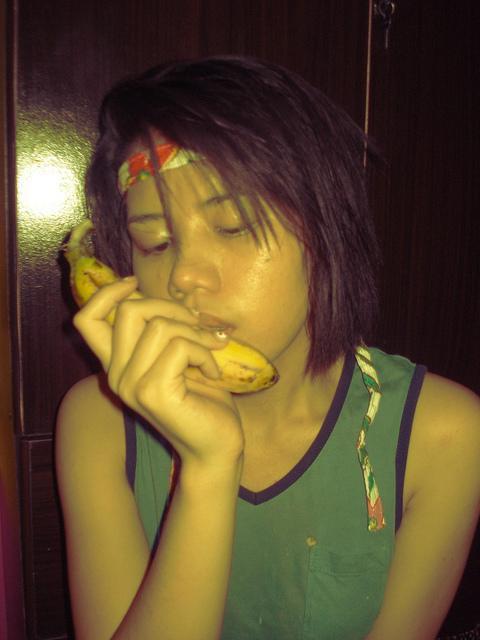How many bananas are visible?
Give a very brief answer. 1. 